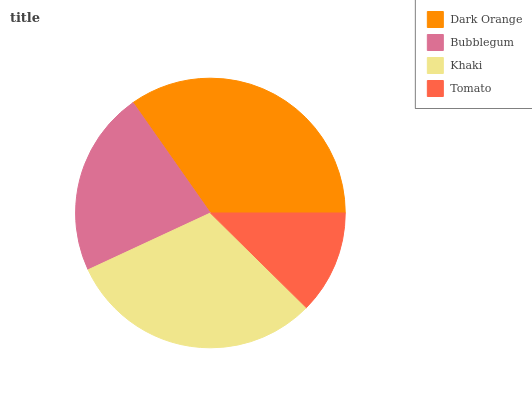Is Tomato the minimum?
Answer yes or no. Yes. Is Dark Orange the maximum?
Answer yes or no. Yes. Is Bubblegum the minimum?
Answer yes or no. No. Is Bubblegum the maximum?
Answer yes or no. No. Is Dark Orange greater than Bubblegum?
Answer yes or no. Yes. Is Bubblegum less than Dark Orange?
Answer yes or no. Yes. Is Bubblegum greater than Dark Orange?
Answer yes or no. No. Is Dark Orange less than Bubblegum?
Answer yes or no. No. Is Khaki the high median?
Answer yes or no. Yes. Is Bubblegum the low median?
Answer yes or no. Yes. Is Tomato the high median?
Answer yes or no. No. Is Dark Orange the low median?
Answer yes or no. No. 